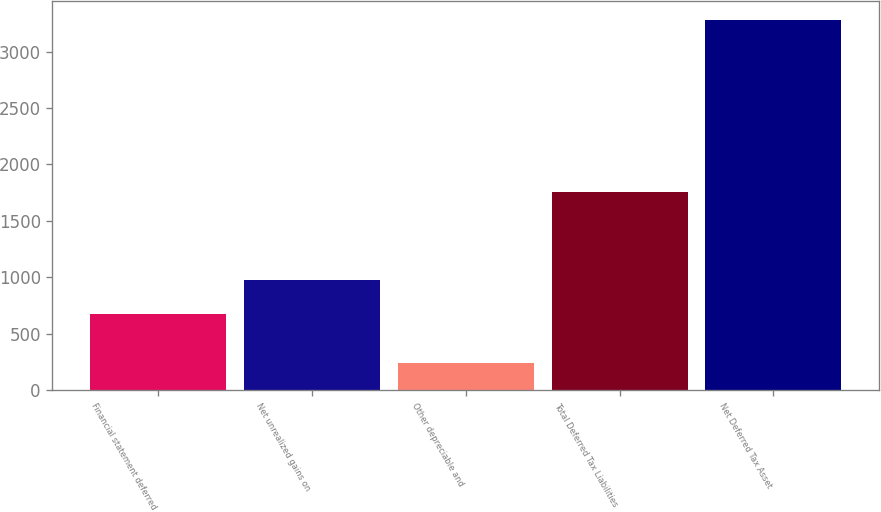Convert chart. <chart><loc_0><loc_0><loc_500><loc_500><bar_chart><fcel>Financial statement deferred<fcel>Net unrealized gains on<fcel>Other depreciable and<fcel>Total Deferred Tax Liabilities<fcel>Net Deferred Tax Asset<nl><fcel>676<fcel>979.8<fcel>243<fcel>1756<fcel>3281<nl></chart> 